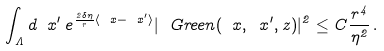Convert formula to latex. <formula><loc_0><loc_0><loc_500><loc_500>\int _ { \Lambda } d \ x ^ { \prime } \, e ^ { { \frac { 2 \delta \eta } { r } \langle \ x - \ x ^ { \prime } \rangle } } | \ G r e e n ( \ x , \ x ^ { \prime } , z ) | ^ { 2 } \leq C \frac { r ^ { 4 } } { \eta ^ { 2 } } \, .</formula> 